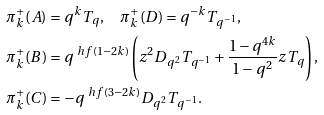Convert formula to latex. <formula><loc_0><loc_0><loc_500><loc_500>\pi ^ { + } _ { k } ( A ) & = q ^ { k } T _ { q } , \quad \pi ^ { + } _ { k } ( D ) = q ^ { - k } T _ { q ^ { - 1 } } , \\ \pi ^ { + } _ { k } ( B ) & = q ^ { \ h f ( 1 - 2 k ) } \left ( z ^ { 2 } D _ { q ^ { 2 } } T _ { q ^ { - 1 } } + \frac { 1 - q ^ { 4 k } } { 1 - q ^ { 2 } } z T _ { q } \right ) , \\ \pi ^ { + } _ { k } ( C ) & = - q ^ { \ h f ( 3 - 2 k ) } D _ { q ^ { 2 } } T _ { q ^ { - 1 } } .</formula> 